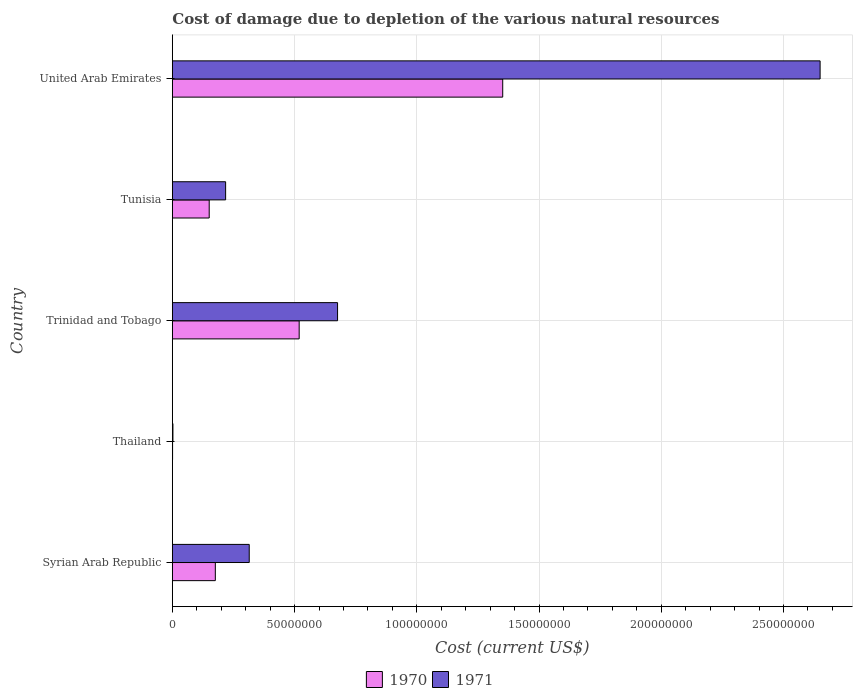How many groups of bars are there?
Ensure brevity in your answer.  5. Are the number of bars on each tick of the Y-axis equal?
Your answer should be very brief. Yes. How many bars are there on the 5th tick from the top?
Make the answer very short. 2. What is the label of the 1st group of bars from the top?
Make the answer very short. United Arab Emirates. In how many cases, is the number of bars for a given country not equal to the number of legend labels?
Provide a short and direct response. 0. What is the cost of damage caused due to the depletion of various natural resources in 1971 in Thailand?
Your answer should be very brief. 2.43e+05. Across all countries, what is the maximum cost of damage caused due to the depletion of various natural resources in 1970?
Offer a terse response. 1.35e+08. Across all countries, what is the minimum cost of damage caused due to the depletion of various natural resources in 1970?
Provide a short and direct response. 9.00e+04. In which country was the cost of damage caused due to the depletion of various natural resources in 1970 maximum?
Your response must be concise. United Arab Emirates. In which country was the cost of damage caused due to the depletion of various natural resources in 1971 minimum?
Give a very brief answer. Thailand. What is the total cost of damage caused due to the depletion of various natural resources in 1971 in the graph?
Offer a very short reply. 3.86e+08. What is the difference between the cost of damage caused due to the depletion of various natural resources in 1971 in Trinidad and Tobago and that in Tunisia?
Make the answer very short. 4.58e+07. What is the difference between the cost of damage caused due to the depletion of various natural resources in 1970 in Syrian Arab Republic and the cost of damage caused due to the depletion of various natural resources in 1971 in Tunisia?
Make the answer very short. -4.21e+06. What is the average cost of damage caused due to the depletion of various natural resources in 1970 per country?
Provide a short and direct response. 4.40e+07. What is the difference between the cost of damage caused due to the depletion of various natural resources in 1971 and cost of damage caused due to the depletion of various natural resources in 1970 in Tunisia?
Provide a succinct answer. 6.72e+06. What is the ratio of the cost of damage caused due to the depletion of various natural resources in 1970 in Syrian Arab Republic to that in United Arab Emirates?
Provide a short and direct response. 0.13. Is the cost of damage caused due to the depletion of various natural resources in 1970 in Trinidad and Tobago less than that in Tunisia?
Your response must be concise. No. What is the difference between the highest and the second highest cost of damage caused due to the depletion of various natural resources in 1970?
Your answer should be very brief. 8.33e+07. What is the difference between the highest and the lowest cost of damage caused due to the depletion of various natural resources in 1970?
Offer a very short reply. 1.35e+08. What does the 2nd bar from the bottom in Trinidad and Tobago represents?
Offer a terse response. 1971. How many countries are there in the graph?
Your answer should be very brief. 5. What is the difference between two consecutive major ticks on the X-axis?
Keep it short and to the point. 5.00e+07. Does the graph contain any zero values?
Provide a short and direct response. No. Does the graph contain grids?
Give a very brief answer. Yes. Where does the legend appear in the graph?
Make the answer very short. Bottom center. What is the title of the graph?
Provide a succinct answer. Cost of damage due to depletion of the various natural resources. What is the label or title of the X-axis?
Provide a short and direct response. Cost (current US$). What is the label or title of the Y-axis?
Your answer should be very brief. Country. What is the Cost (current US$) in 1970 in Syrian Arab Republic?
Offer a very short reply. 1.76e+07. What is the Cost (current US$) of 1971 in Syrian Arab Republic?
Your answer should be very brief. 3.14e+07. What is the Cost (current US$) in 1970 in Thailand?
Provide a succinct answer. 9.00e+04. What is the Cost (current US$) of 1971 in Thailand?
Give a very brief answer. 2.43e+05. What is the Cost (current US$) in 1970 in Trinidad and Tobago?
Your answer should be compact. 5.19e+07. What is the Cost (current US$) in 1971 in Trinidad and Tobago?
Offer a terse response. 6.76e+07. What is the Cost (current US$) of 1970 in Tunisia?
Give a very brief answer. 1.51e+07. What is the Cost (current US$) in 1971 in Tunisia?
Your response must be concise. 2.18e+07. What is the Cost (current US$) of 1970 in United Arab Emirates?
Provide a succinct answer. 1.35e+08. What is the Cost (current US$) of 1971 in United Arab Emirates?
Your response must be concise. 2.65e+08. Across all countries, what is the maximum Cost (current US$) of 1970?
Your response must be concise. 1.35e+08. Across all countries, what is the maximum Cost (current US$) in 1971?
Your answer should be very brief. 2.65e+08. Across all countries, what is the minimum Cost (current US$) of 1970?
Offer a terse response. 9.00e+04. Across all countries, what is the minimum Cost (current US$) of 1971?
Provide a succinct answer. 2.43e+05. What is the total Cost (current US$) in 1970 in the graph?
Provide a succinct answer. 2.20e+08. What is the total Cost (current US$) of 1971 in the graph?
Give a very brief answer. 3.86e+08. What is the difference between the Cost (current US$) in 1970 in Syrian Arab Republic and that in Thailand?
Provide a short and direct response. 1.75e+07. What is the difference between the Cost (current US$) in 1971 in Syrian Arab Republic and that in Thailand?
Keep it short and to the point. 3.12e+07. What is the difference between the Cost (current US$) of 1970 in Syrian Arab Republic and that in Trinidad and Tobago?
Your response must be concise. -3.43e+07. What is the difference between the Cost (current US$) in 1971 in Syrian Arab Republic and that in Trinidad and Tobago?
Provide a short and direct response. -3.61e+07. What is the difference between the Cost (current US$) of 1970 in Syrian Arab Republic and that in Tunisia?
Provide a succinct answer. 2.51e+06. What is the difference between the Cost (current US$) in 1971 in Syrian Arab Republic and that in Tunisia?
Offer a terse response. 9.65e+06. What is the difference between the Cost (current US$) of 1970 in Syrian Arab Republic and that in United Arab Emirates?
Give a very brief answer. -1.18e+08. What is the difference between the Cost (current US$) in 1971 in Syrian Arab Republic and that in United Arab Emirates?
Give a very brief answer. -2.34e+08. What is the difference between the Cost (current US$) of 1970 in Thailand and that in Trinidad and Tobago?
Offer a terse response. -5.18e+07. What is the difference between the Cost (current US$) in 1971 in Thailand and that in Trinidad and Tobago?
Your response must be concise. -6.73e+07. What is the difference between the Cost (current US$) of 1970 in Thailand and that in Tunisia?
Make the answer very short. -1.50e+07. What is the difference between the Cost (current US$) in 1971 in Thailand and that in Tunisia?
Your answer should be compact. -2.16e+07. What is the difference between the Cost (current US$) in 1970 in Thailand and that in United Arab Emirates?
Keep it short and to the point. -1.35e+08. What is the difference between the Cost (current US$) of 1971 in Thailand and that in United Arab Emirates?
Give a very brief answer. -2.65e+08. What is the difference between the Cost (current US$) of 1970 in Trinidad and Tobago and that in Tunisia?
Your answer should be very brief. 3.68e+07. What is the difference between the Cost (current US$) in 1971 in Trinidad and Tobago and that in Tunisia?
Offer a terse response. 4.58e+07. What is the difference between the Cost (current US$) of 1970 in Trinidad and Tobago and that in United Arab Emirates?
Offer a very short reply. -8.33e+07. What is the difference between the Cost (current US$) of 1971 in Trinidad and Tobago and that in United Arab Emirates?
Make the answer very short. -1.97e+08. What is the difference between the Cost (current US$) of 1970 in Tunisia and that in United Arab Emirates?
Give a very brief answer. -1.20e+08. What is the difference between the Cost (current US$) in 1971 in Tunisia and that in United Arab Emirates?
Provide a short and direct response. -2.43e+08. What is the difference between the Cost (current US$) of 1970 in Syrian Arab Republic and the Cost (current US$) of 1971 in Thailand?
Your answer should be compact. 1.73e+07. What is the difference between the Cost (current US$) of 1970 in Syrian Arab Republic and the Cost (current US$) of 1971 in Trinidad and Tobago?
Offer a terse response. -5.00e+07. What is the difference between the Cost (current US$) of 1970 in Syrian Arab Republic and the Cost (current US$) of 1971 in Tunisia?
Keep it short and to the point. -4.21e+06. What is the difference between the Cost (current US$) of 1970 in Syrian Arab Republic and the Cost (current US$) of 1971 in United Arab Emirates?
Provide a short and direct response. -2.47e+08. What is the difference between the Cost (current US$) in 1970 in Thailand and the Cost (current US$) in 1971 in Trinidad and Tobago?
Your answer should be compact. -6.75e+07. What is the difference between the Cost (current US$) of 1970 in Thailand and the Cost (current US$) of 1971 in Tunisia?
Your answer should be compact. -2.17e+07. What is the difference between the Cost (current US$) of 1970 in Thailand and the Cost (current US$) of 1971 in United Arab Emirates?
Your response must be concise. -2.65e+08. What is the difference between the Cost (current US$) of 1970 in Trinidad and Tobago and the Cost (current US$) of 1971 in Tunisia?
Keep it short and to the point. 3.01e+07. What is the difference between the Cost (current US$) of 1970 in Trinidad and Tobago and the Cost (current US$) of 1971 in United Arab Emirates?
Keep it short and to the point. -2.13e+08. What is the difference between the Cost (current US$) in 1970 in Tunisia and the Cost (current US$) in 1971 in United Arab Emirates?
Make the answer very short. -2.50e+08. What is the average Cost (current US$) in 1970 per country?
Keep it short and to the point. 4.40e+07. What is the average Cost (current US$) of 1971 per country?
Offer a terse response. 7.72e+07. What is the difference between the Cost (current US$) of 1970 and Cost (current US$) of 1971 in Syrian Arab Republic?
Your response must be concise. -1.39e+07. What is the difference between the Cost (current US$) of 1970 and Cost (current US$) of 1971 in Thailand?
Your answer should be compact. -1.53e+05. What is the difference between the Cost (current US$) of 1970 and Cost (current US$) of 1971 in Trinidad and Tobago?
Provide a short and direct response. -1.57e+07. What is the difference between the Cost (current US$) in 1970 and Cost (current US$) in 1971 in Tunisia?
Keep it short and to the point. -6.72e+06. What is the difference between the Cost (current US$) of 1970 and Cost (current US$) of 1971 in United Arab Emirates?
Offer a terse response. -1.30e+08. What is the ratio of the Cost (current US$) of 1970 in Syrian Arab Republic to that in Thailand?
Offer a terse response. 195.44. What is the ratio of the Cost (current US$) in 1971 in Syrian Arab Republic to that in Thailand?
Provide a succinct answer. 129.33. What is the ratio of the Cost (current US$) of 1970 in Syrian Arab Republic to that in Trinidad and Tobago?
Your answer should be compact. 0.34. What is the ratio of the Cost (current US$) of 1971 in Syrian Arab Republic to that in Trinidad and Tobago?
Your response must be concise. 0.47. What is the ratio of the Cost (current US$) in 1970 in Syrian Arab Republic to that in Tunisia?
Keep it short and to the point. 1.17. What is the ratio of the Cost (current US$) of 1971 in Syrian Arab Republic to that in Tunisia?
Provide a succinct answer. 1.44. What is the ratio of the Cost (current US$) in 1970 in Syrian Arab Republic to that in United Arab Emirates?
Provide a succinct answer. 0.13. What is the ratio of the Cost (current US$) in 1971 in Syrian Arab Republic to that in United Arab Emirates?
Provide a short and direct response. 0.12. What is the ratio of the Cost (current US$) in 1970 in Thailand to that in Trinidad and Tobago?
Provide a short and direct response. 0. What is the ratio of the Cost (current US$) of 1971 in Thailand to that in Trinidad and Tobago?
Provide a short and direct response. 0. What is the ratio of the Cost (current US$) in 1970 in Thailand to that in Tunisia?
Offer a very short reply. 0.01. What is the ratio of the Cost (current US$) in 1971 in Thailand to that in Tunisia?
Ensure brevity in your answer.  0.01. What is the ratio of the Cost (current US$) in 1970 in Thailand to that in United Arab Emirates?
Your answer should be compact. 0. What is the ratio of the Cost (current US$) in 1971 in Thailand to that in United Arab Emirates?
Keep it short and to the point. 0. What is the ratio of the Cost (current US$) of 1970 in Trinidad and Tobago to that in Tunisia?
Offer a very short reply. 3.44. What is the ratio of the Cost (current US$) of 1971 in Trinidad and Tobago to that in Tunisia?
Provide a short and direct response. 3.1. What is the ratio of the Cost (current US$) of 1970 in Trinidad and Tobago to that in United Arab Emirates?
Provide a succinct answer. 0.38. What is the ratio of the Cost (current US$) of 1971 in Trinidad and Tobago to that in United Arab Emirates?
Provide a short and direct response. 0.26. What is the ratio of the Cost (current US$) of 1970 in Tunisia to that in United Arab Emirates?
Your response must be concise. 0.11. What is the ratio of the Cost (current US$) in 1971 in Tunisia to that in United Arab Emirates?
Offer a very short reply. 0.08. What is the difference between the highest and the second highest Cost (current US$) of 1970?
Make the answer very short. 8.33e+07. What is the difference between the highest and the second highest Cost (current US$) of 1971?
Ensure brevity in your answer.  1.97e+08. What is the difference between the highest and the lowest Cost (current US$) in 1970?
Your answer should be very brief. 1.35e+08. What is the difference between the highest and the lowest Cost (current US$) in 1971?
Offer a terse response. 2.65e+08. 